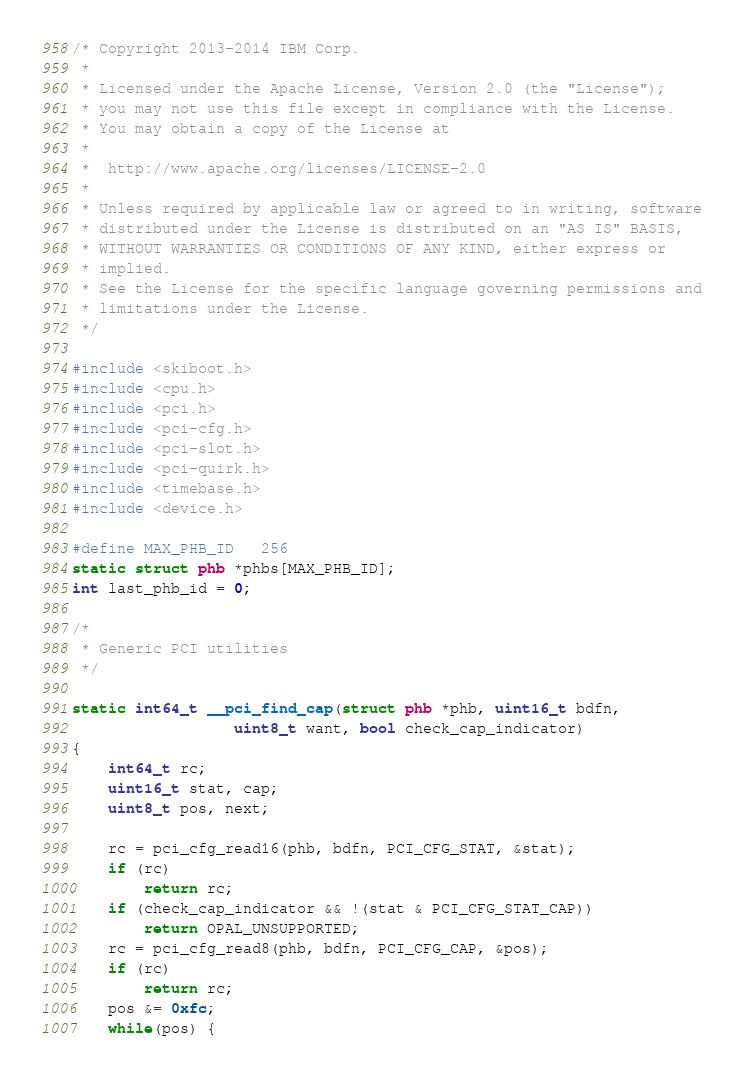Convert code to text. <code><loc_0><loc_0><loc_500><loc_500><_C_>/* Copyright 2013-2014 IBM Corp.
 *
 * Licensed under the Apache License, Version 2.0 (the "License");
 * you may not use this file except in compliance with the License.
 * You may obtain a copy of the License at
 *
 * 	http://www.apache.org/licenses/LICENSE-2.0
 *
 * Unless required by applicable law or agreed to in writing, software
 * distributed under the License is distributed on an "AS IS" BASIS,
 * WITHOUT WARRANTIES OR CONDITIONS OF ANY KIND, either express or
 * implied.
 * See the License for the specific language governing permissions and
 * limitations under the License.
 */

#include <skiboot.h>
#include <cpu.h>
#include <pci.h>
#include <pci-cfg.h>
#include <pci-slot.h>
#include <pci-quirk.h>
#include <timebase.h>
#include <device.h>

#define MAX_PHB_ID	256
static struct phb *phbs[MAX_PHB_ID];
int last_phb_id = 0;

/*
 * Generic PCI utilities
 */

static int64_t __pci_find_cap(struct phb *phb, uint16_t bdfn,
			      uint8_t want, bool check_cap_indicator)
{
	int64_t rc;
	uint16_t stat, cap;
	uint8_t pos, next;

	rc = pci_cfg_read16(phb, bdfn, PCI_CFG_STAT, &stat);
	if (rc)
		return rc;
	if (check_cap_indicator && !(stat & PCI_CFG_STAT_CAP))
		return OPAL_UNSUPPORTED;
	rc = pci_cfg_read8(phb, bdfn, PCI_CFG_CAP, &pos);
	if (rc)
		return rc;
	pos &= 0xfc;
	while(pos) {</code> 